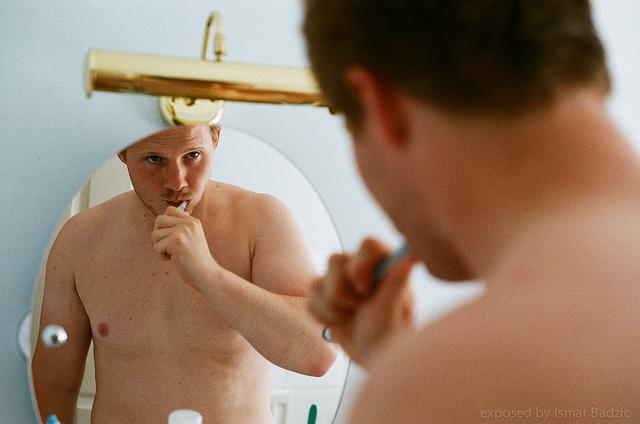Does this man workout often?
Short answer required. No. What is the man doing?
Write a very short answer. Brushing teeth. Is this person hungry?
Concise answer only. No. What color is the man's hair?
Quick response, please. Brown. 